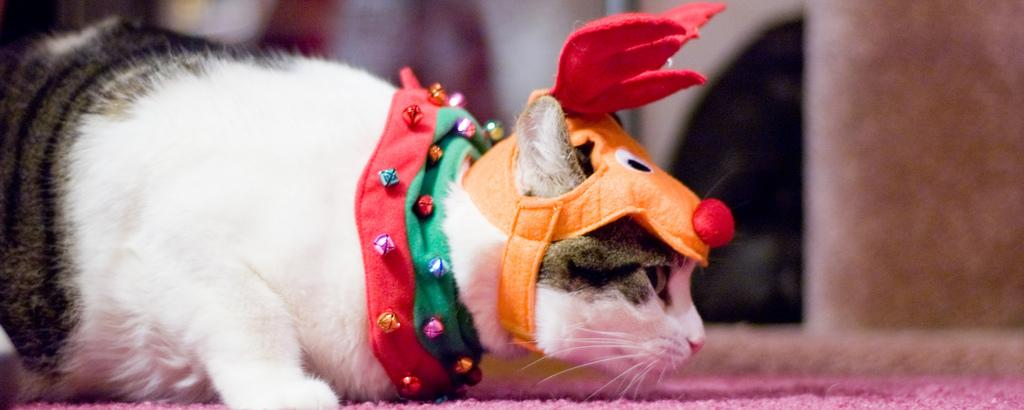What type of animal is in the image? There is a cat in the image. What is the cat wearing? The cat is wearing an orange color cap. What can be seen in the background of the image? There is a wall visible in the background of the image. What is at the bottom of the image? There is a pink color mat at the bottom of the image. What type of rice is being served on the cat's finger in the image? There is no rice or finger present in the image; it features a cat wearing an orange color cap with a wall in the background and a pink color mat at the bottom. 